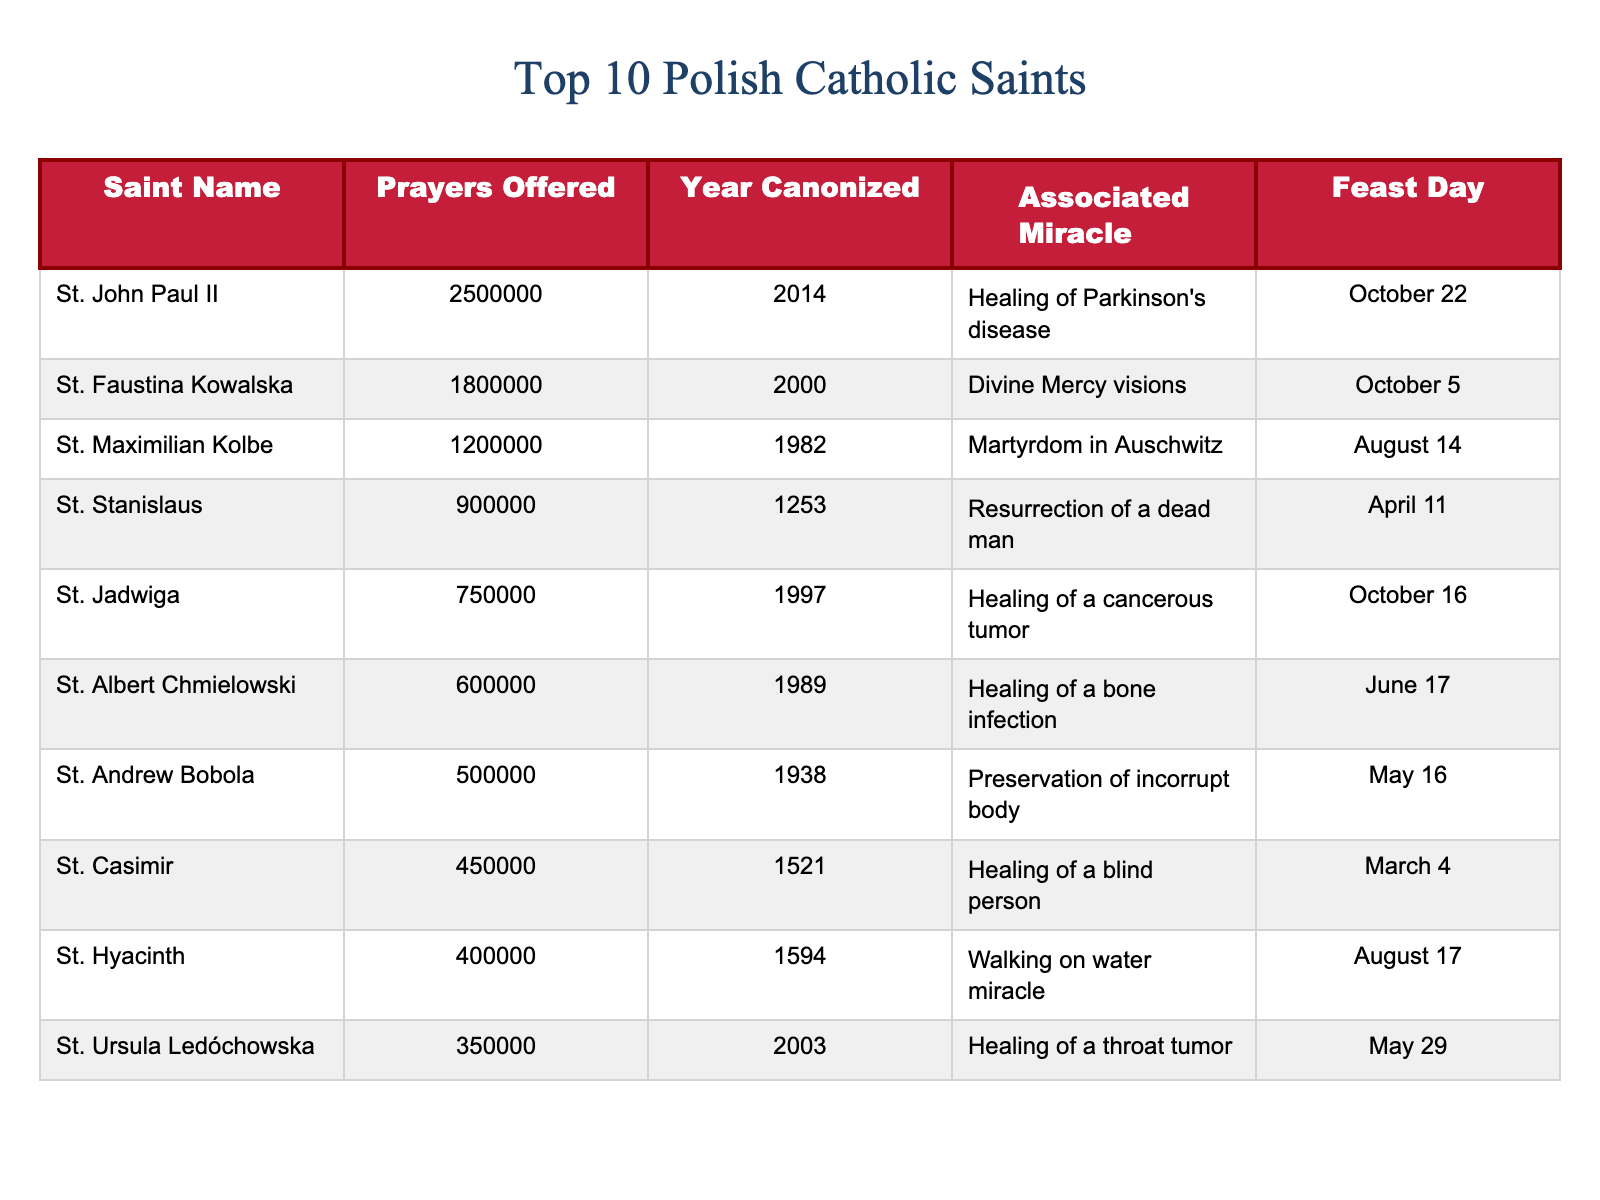What is the name of the saint with the highest number of prayers offered? By looking at the "Prayers Offered" column, we see that St. John Paul II has the highest number of prayers at 2,500,000.
Answer: St. John Paul II How many prayers were offered for St. Maximilian Kolbe? Referring to the "Prayers Offered" column, Saint Maximilian Kolbe has 1,200,000 prayers offered.
Answer: 1,200,000 What year was St. Faustina Kowalska canonized? The "Year Canonized" column indicates that St. Faustina Kowalska was canonized in 2000.
Answer: 2000 Which saint has the associated miracle of "Walking on water miracle"? A quick look at the "Associated Miracle" column shows that St. Hyacinth has this specific miracle listed.
Answer: St. Hyacinth Is St. Jadwiga's feast day in October? By checking the "Feast Day" column, we find that St. Jadwiga's feast day is on October 16, confirming it is indeed in October.
Answer: Yes What is the total number of prayers offered for the top three saints? The total can be calculated by summing the prayers of St. John Paul II (2,500,000), St. Faustina Kowalska (1,800,000), and St. Maximilian Kolbe (1,200,000), resulting in 2,500,000 + 1,800,000 + 1,200,000 = 5,500,000.
Answer: 5,500,000 Which saint was associated with the miracle of "Martyrdom in Auschwitz"? The associated miracle of "Martyrdom in Auschwitz" belongs to St. Maximilian Kolbe, as noted in the "Associated Miracle" column.
Answer: St. Maximilian Kolbe Do more prayers exist for St. Albert Chmielowski than for St. Andrew Bobola? Comparing the "Prayers Offered," St. Albert Chmielowski has 600,000 prayers, while St. Andrew Bobola has 500,000 prayers, thus confirming that St. Albert has more.
Answer: Yes What is the average number of prayers offered for the listed saints? To find the average, we sum all the prayers: 2,500,000 + 1,800,000 + 1,200,000 + 900,000 + 750,000 + 600,000 + 500,000 + 450,000 + 400,000 + 350,000 = 8,650,000. Dividing by the number of saints (10) gives an average of 865,000.
Answer: 865,000 Which saint has the latest canonization year? St. John Paul II was canonized in 2014, which is the latest year shown in the "Year Canonized" column, thus making him the most recently canonized saint.
Answer: St. John Paul II 